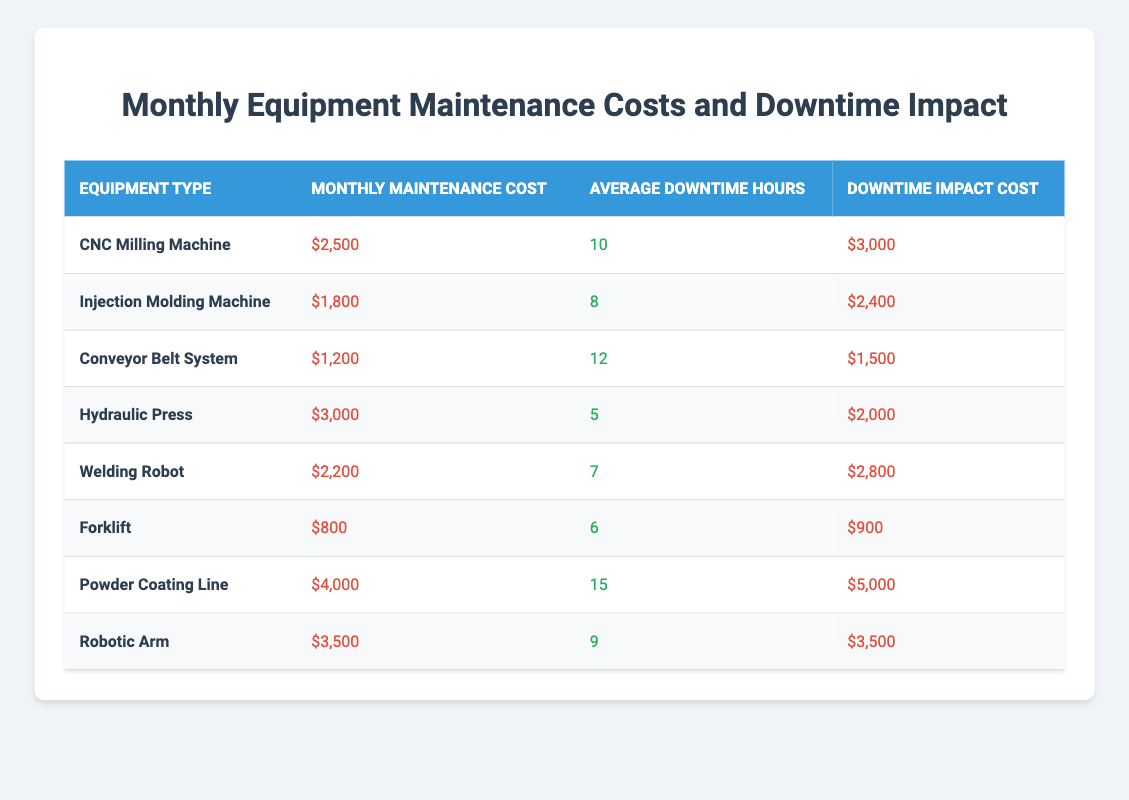What is the Monthly Maintenance Cost of the CNC Milling Machine? The Monthly Maintenance Cost of the CNC Milling Machine is listed directly in the table. It shows $2,500 for this equipment.
Answer: $2,500 What is the Average Downtime Hours for the Forklift? The Average Downtime Hours for the Forklift is stated directly in the table as 6 hours.
Answer: 6 hours Which equipment has the highest Downtime Impact Cost? By reviewing the Downtime Impact Cost section of the table, the Powder Coating Line has the highest reported cost of $5,000.
Answer: Powder Coating Line What is the total Monthly Maintenance Cost for all equipment types? The Monthly Maintenance Costs are summed up as follows: $2,500 + $1,800 + $1,200 + $3,000 + $2,200 + $800 + $4,000 + $3,500 = $19,000.
Answer: $19,000 How much is the difference in Monthly Maintenance Cost between the Hydraulic Press and the Welding Robot? The Monthly Maintenance Cost of the Hydraulic Press is $3,000 and the Welding Robot is $2,200. The difference is $3,000 - $2,200 = $800.
Answer: $800 What is the average Downtime Impact Cost for all the equipment types? To find the average, sum the Downtime Impact Costs: $3,000 + $2,400 + $1,500 + $2,000 + $2,800 + $900 + $5,000 + $3,500 = $21,100. Then divide by the number of equipment types, which is 8: $21,100 / 8 = $2,637.50.
Answer: $2,637.50 Does the Injection Molding Machine have a higher Downtime Impact Cost than the Forklift? The Downtime Impact Cost for the Injection Molding Machine is $2,400 and for the Forklift is $900. Since $2,400 is greater than $900, the statement is true.
Answer: Yes Which equipment type has the least average downtime hours? The Forklift has the least average downtime hours, with 6 hours, compared to all other equipment types listed.
Answer: Forklift What is the total Downtime Impact Cost for equipment with Monthly Maintenance Costs above $2,500? The equipment types with Monthly Maintenance Costs above $2,500 are the Hydraulic Press ($2,000), Powder Coating Line ($5,000), and Robotic Arm ($3,500). The total is $2,000 + $5,000 + $3,500 = $10,500.
Answer: $10,500 Which equipment type has the highest ratio of Downtime Impact Cost to Monthly Maintenance Cost? To find the ratio, calculate Downtime Impact Cost divided by Monthly Maintenance Cost for each equipment. The highest ratio is Powder Coating Line: $5,000 / $4,000 = 1.25. This is the largest ratio compared to others.
Answer: Powder Coating Line 